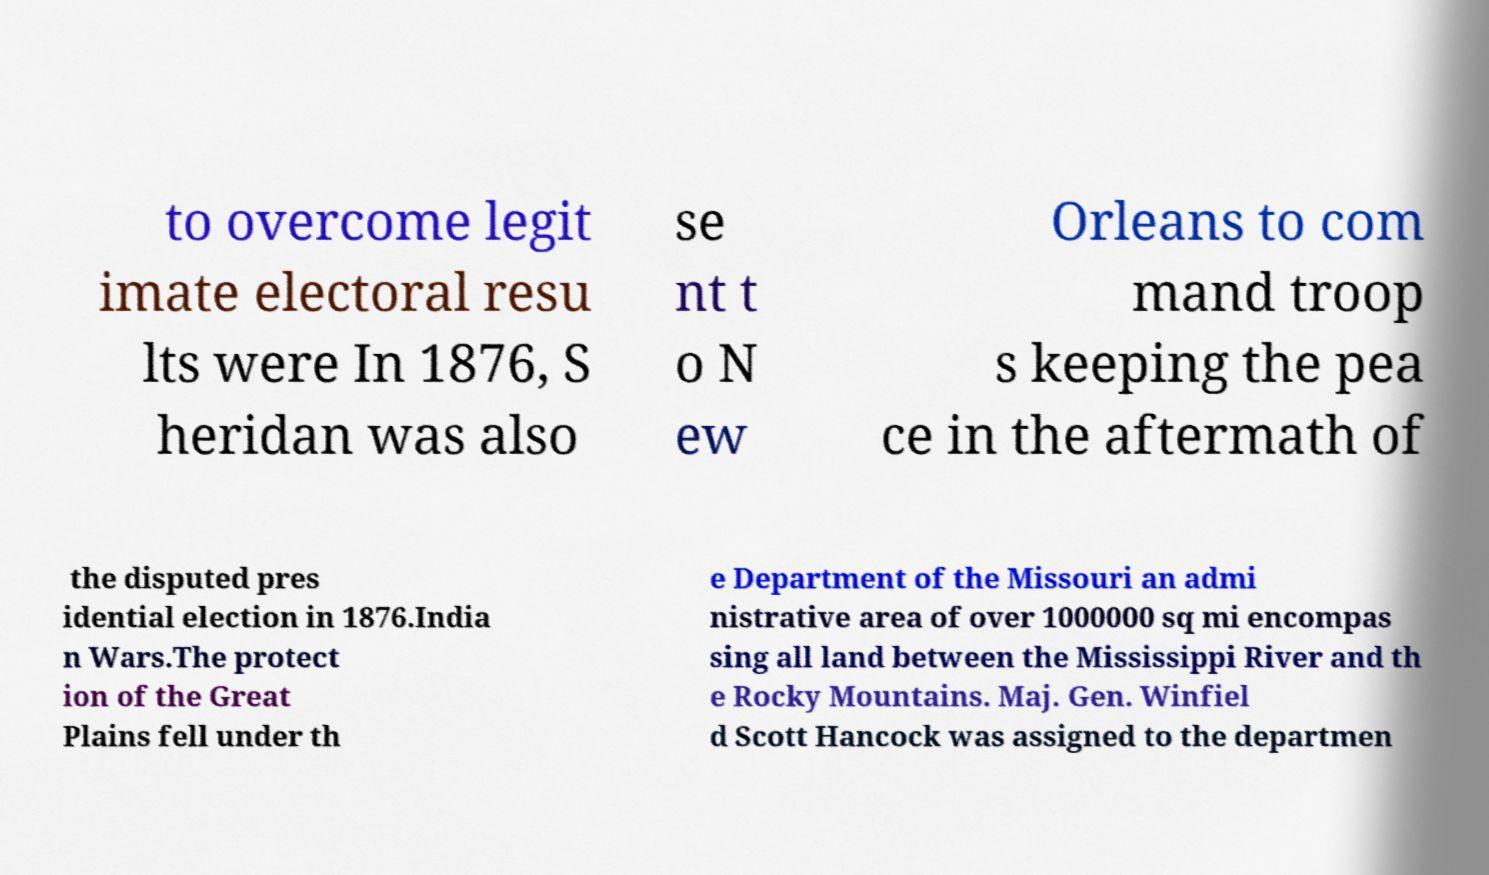Please identify and transcribe the text found in this image. to overcome legit imate electoral resu lts were In 1876, S heridan was also se nt t o N ew Orleans to com mand troop s keeping the pea ce in the aftermath of the disputed pres idential election in 1876.India n Wars.The protect ion of the Great Plains fell under th e Department of the Missouri an admi nistrative area of over 1000000 sq mi encompas sing all land between the Mississippi River and th e Rocky Mountains. Maj. Gen. Winfiel d Scott Hancock was assigned to the departmen 